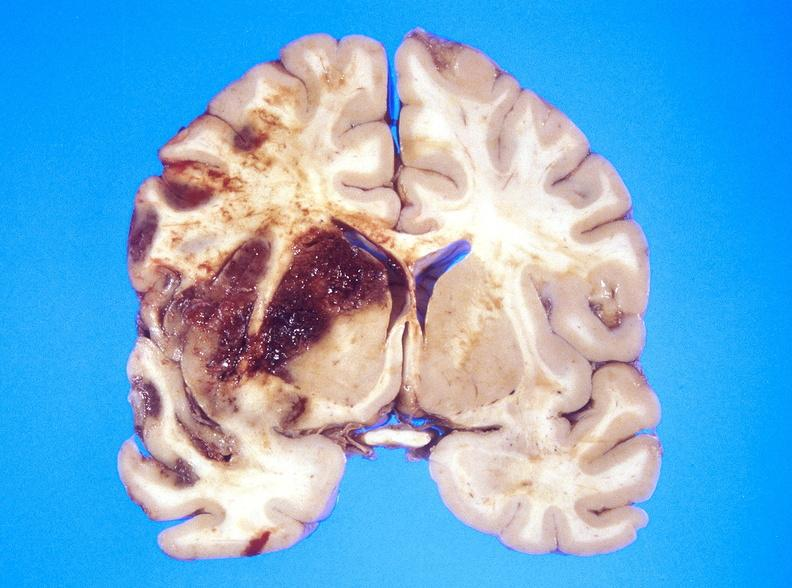does this image show hemorrhagic reperfusion infarct, middle cerebral artery l?
Answer the question using a single word or phrase. Yes 